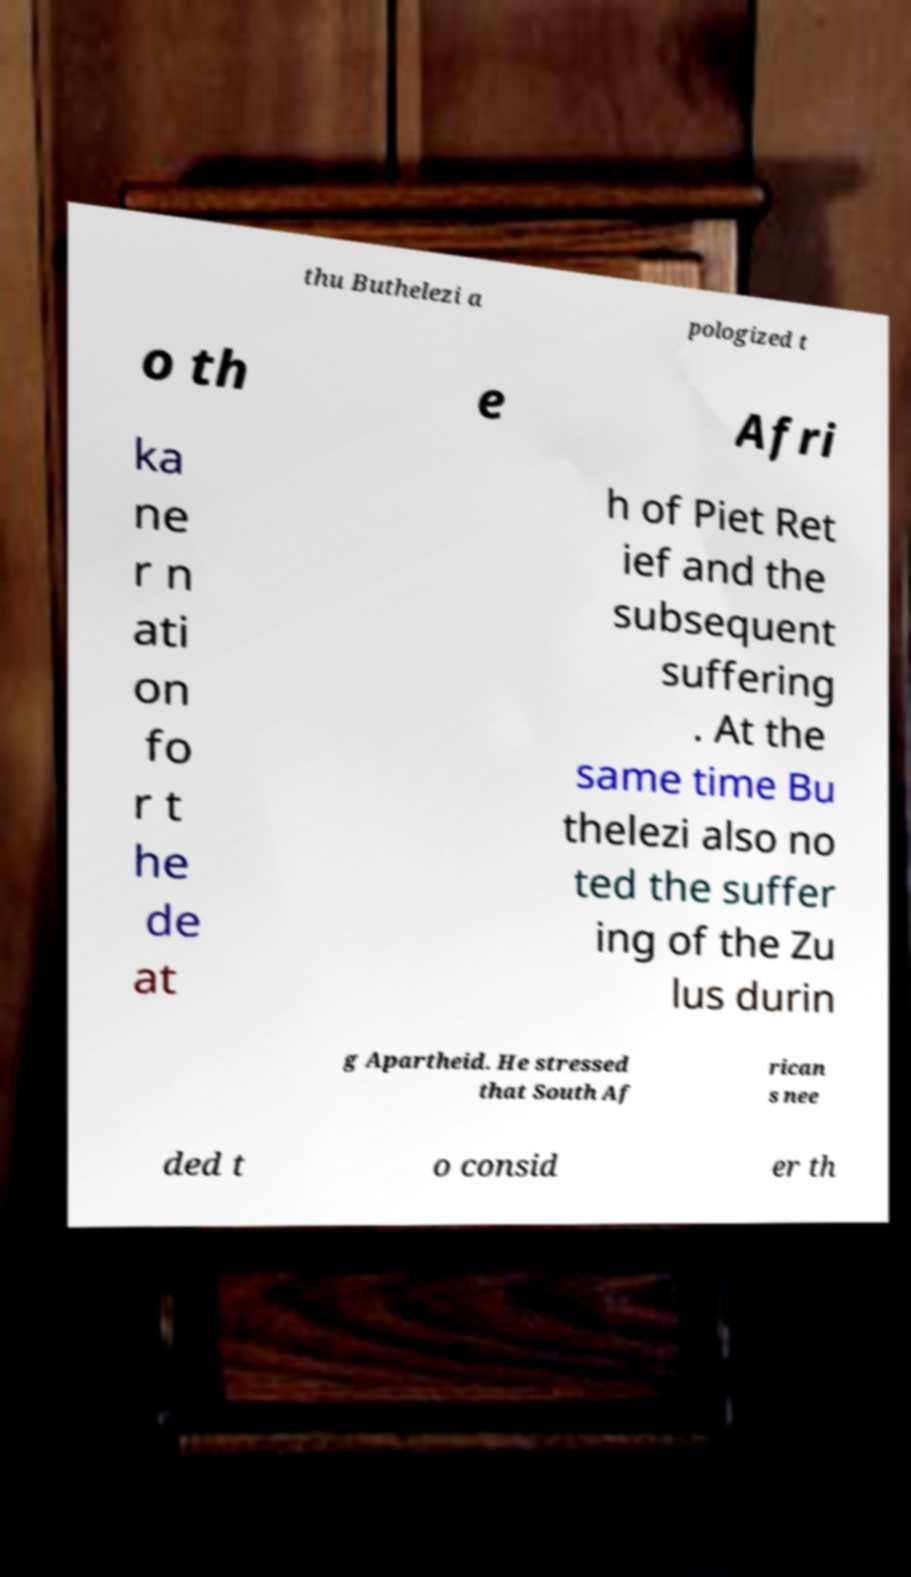Could you extract and type out the text from this image? thu Buthelezi a pologized t o th e Afri ka ne r n ati on fo r t he de at h of Piet Ret ief and the subsequent suffering . At the same time Bu thelezi also no ted the suffer ing of the Zu lus durin g Apartheid. He stressed that South Af rican s nee ded t o consid er th 